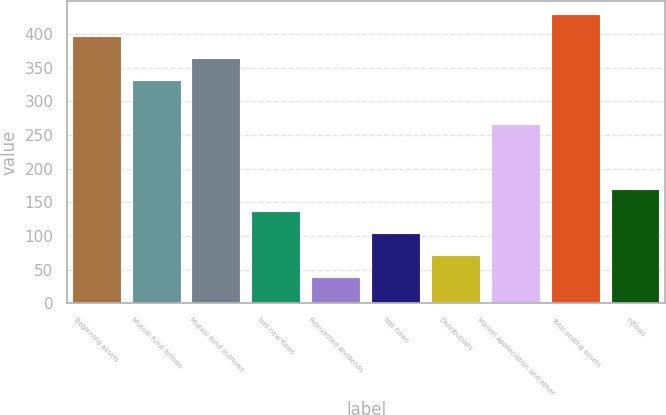Convert chart. <chart><loc_0><loc_0><loc_500><loc_500><bar_chart><fcel>Beginning assets<fcel>Mutual fund inflows<fcel>Mutual fund outflows<fcel>Net new flows<fcel>Reinvested dividends<fcel>Net flows<fcel>Distributions<fcel>Market appreciation and other<fcel>Total ending assets<fcel>Inflows<nl><fcel>395.36<fcel>330.4<fcel>362.88<fcel>135.52<fcel>38.08<fcel>103.04<fcel>70.56<fcel>265.44<fcel>427.84<fcel>168<nl></chart> 